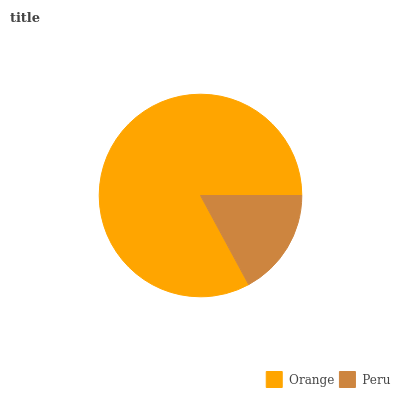Is Peru the minimum?
Answer yes or no. Yes. Is Orange the maximum?
Answer yes or no. Yes. Is Peru the maximum?
Answer yes or no. No. Is Orange greater than Peru?
Answer yes or no. Yes. Is Peru less than Orange?
Answer yes or no. Yes. Is Peru greater than Orange?
Answer yes or no. No. Is Orange less than Peru?
Answer yes or no. No. Is Orange the high median?
Answer yes or no. Yes. Is Peru the low median?
Answer yes or no. Yes. Is Peru the high median?
Answer yes or no. No. Is Orange the low median?
Answer yes or no. No. 